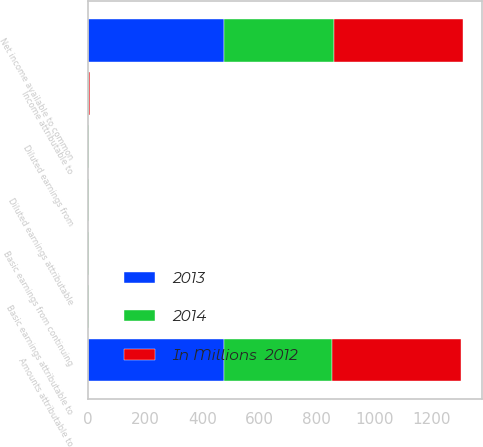<chart> <loc_0><loc_0><loc_500><loc_500><stacked_bar_chart><ecel><fcel>Amounts attributable to<fcel>Net income available to common<fcel>Income attributable to<fcel>Basic earnings from continuing<fcel>Basic earnings attributable to<fcel>Diluted earnings from<fcel>Diluted earnings attributable<nl><fcel>2013<fcel>477<fcel>477<fcel>2<fcel>1.76<fcel>1.76<fcel>1.74<fcel>1.74<nl><fcel>In Millions  2012<fcel>452<fcel>452<fcel>2<fcel>1.71<fcel>1.71<fcel>1.66<fcel>1.66<nl><fcel>2014<fcel>375<fcel>382<fcel>2<fcel>1.43<fcel>1.46<fcel>1.39<fcel>1.42<nl></chart> 